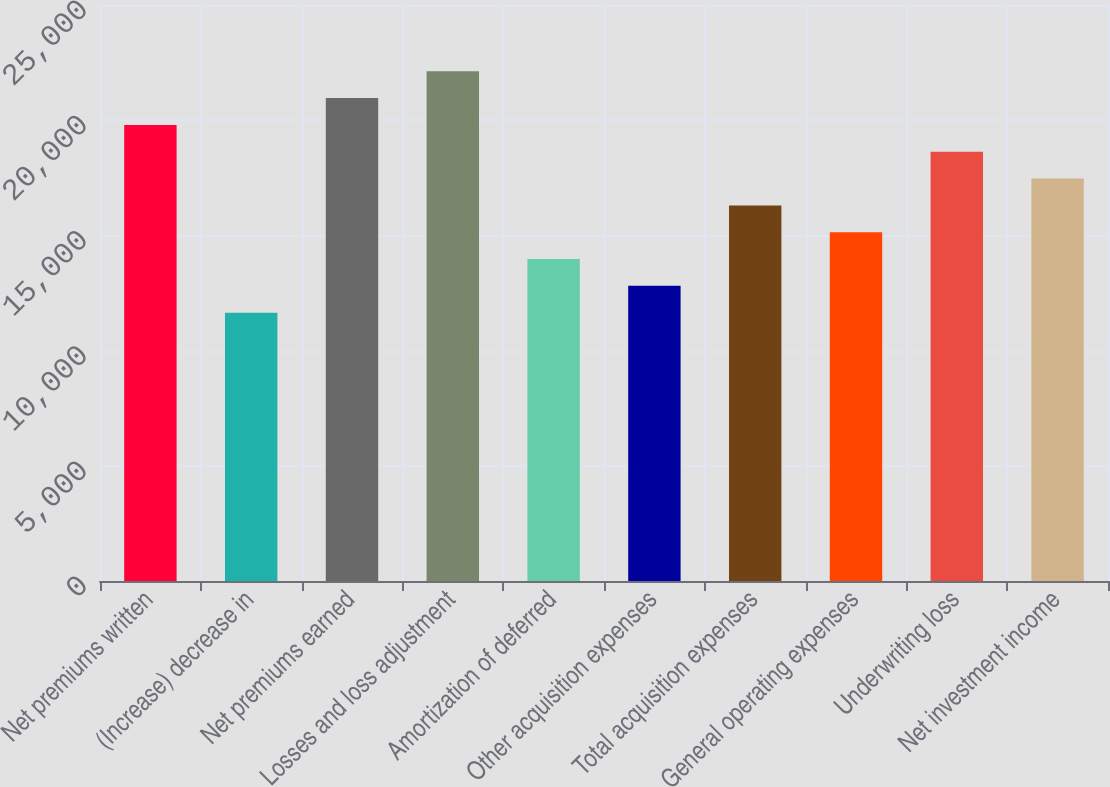Convert chart. <chart><loc_0><loc_0><loc_500><loc_500><bar_chart><fcel>Net premiums written<fcel>(Increase) decrease in<fcel>Net premiums earned<fcel>Losses and loss adjustment<fcel>Amortization of deferred<fcel>Other acquisition expenses<fcel>Total acquisition expenses<fcel>General operating expenses<fcel>Underwriting loss<fcel>Net investment income<nl><fcel>19795.7<fcel>11646<fcel>20959.9<fcel>22124.2<fcel>13974.5<fcel>12810.2<fcel>16303<fcel>15138.7<fcel>18631.4<fcel>17467.2<nl></chart> 